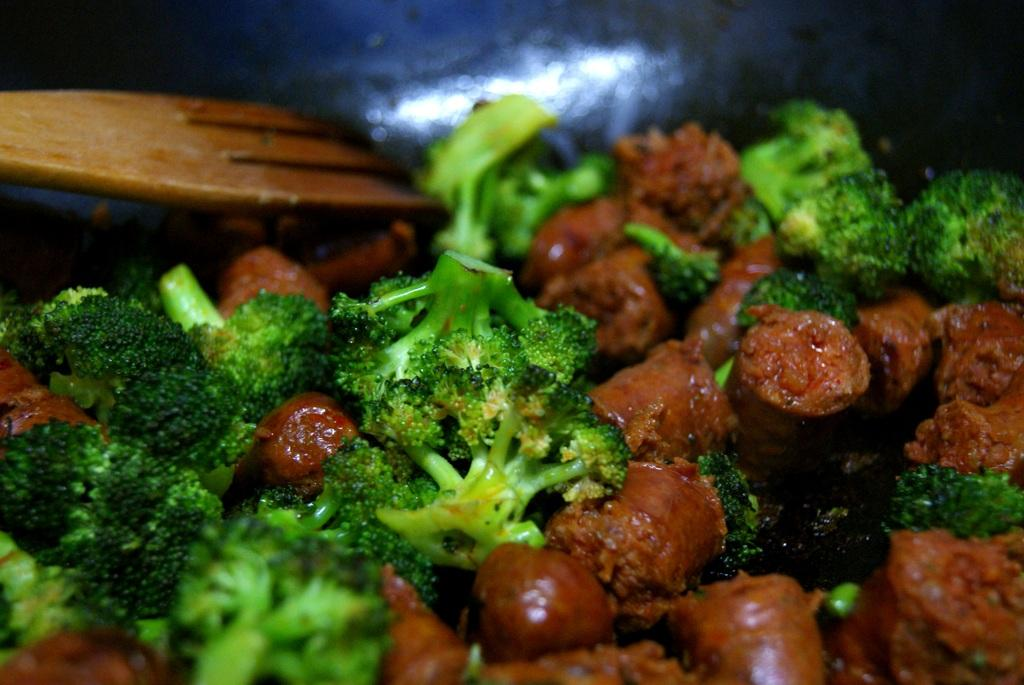What types of items can be seen in the image? There are food items in the image. Can you describe the utensil visible in the image? There is a wooden spoon in the top left corner of the image. What type of rock can be seen in the image? There is no rock present in the image; it features food items and a wooden spoon. Can you tell me how many cats are visible in the image? There are no cats present in the image. 